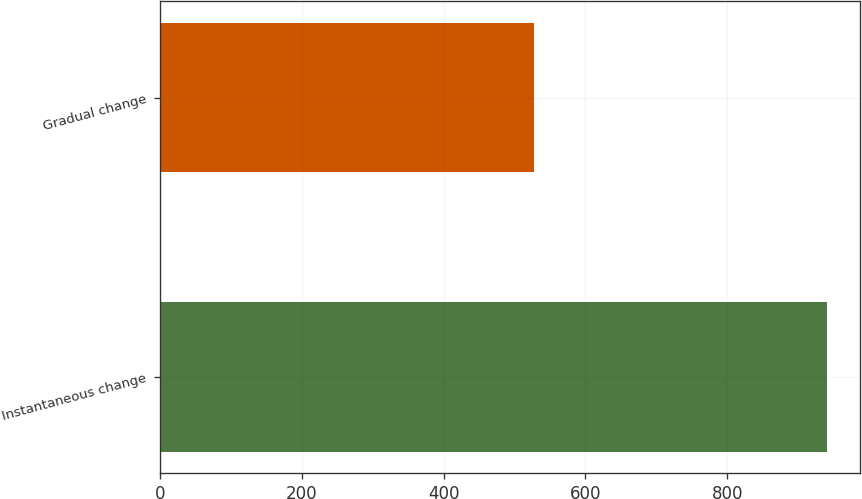Convert chart to OTSL. <chart><loc_0><loc_0><loc_500><loc_500><bar_chart><fcel>Instantaneous change<fcel>Gradual change<nl><fcel>940<fcel>527<nl></chart> 